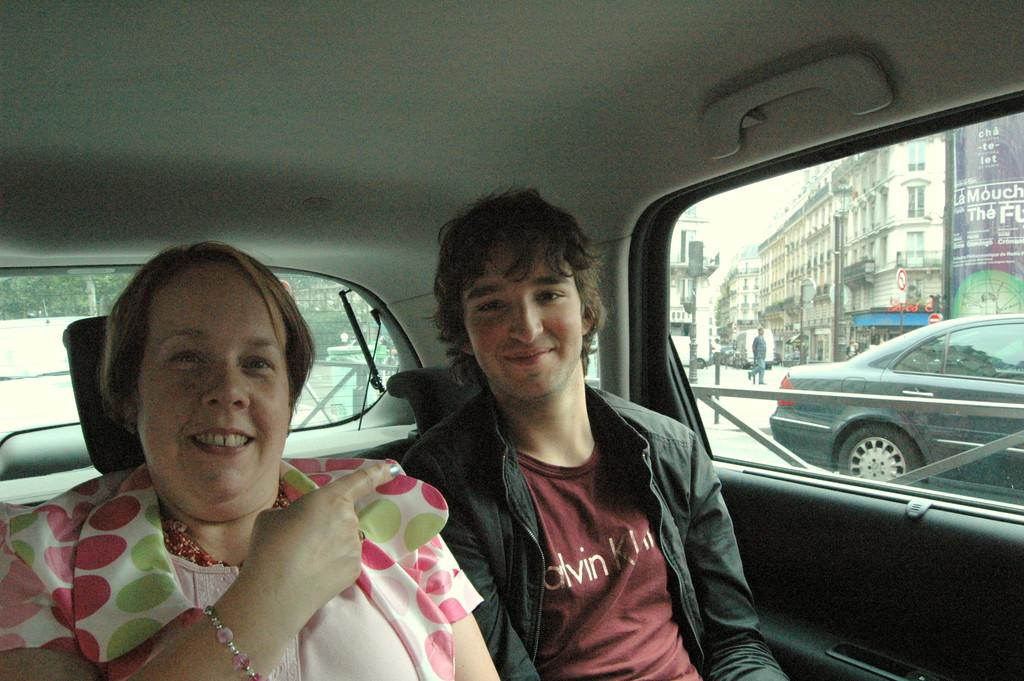How many people are in the image? There are two people in the image. What are the two people doing in the image? The two people are sitting in a car. What type of desk can be seen in the image? There is no desk present in the image; it features two people sitting in a car. How many eggs are visible on the seat of the car in the image? There are no eggs visible in the image; it features two people sitting in a car. 